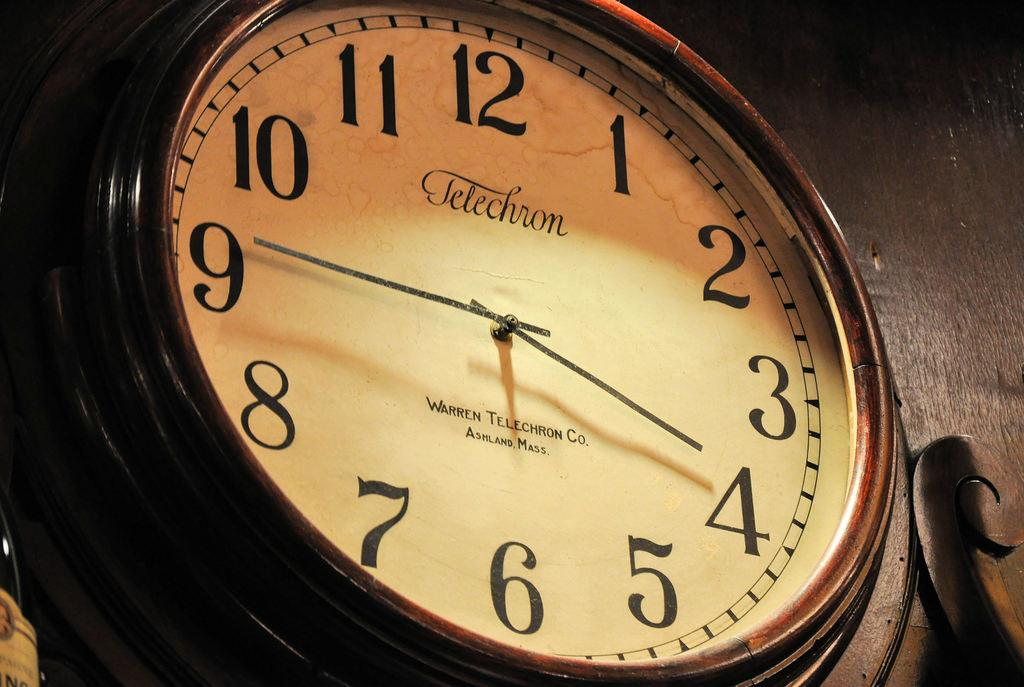<image>
Describe the image concisely. A large wall clock from Telechrom points to the numbers 4 and 9 